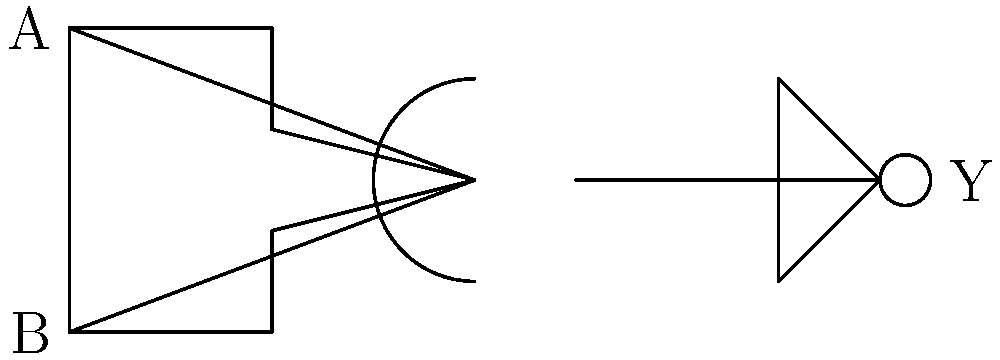In the context of risk assessment for high-tech manufacturing facilities, you encounter a digital circuit schematic. Identify the logic gates in this circuit and determine the truth table for output Y. How might this circuit's behavior relate to a fail-safe mechanism in a manufacturing process? Let's approach this step-by-step:

1) Gate identification:
   - The first gate is an AND gate
   - The second gate is a NOT gate (inverter)

2) Circuit analysis:
   - Inputs A and B feed into the AND gate
   - The output of the AND gate feeds into the NOT gate
   - The output of the NOT gate is Y

3) Truth table construction:
   Let's consider all possible input combinations:

   | A | B | AND output | Y (NOT of AND) |
   |---|---|------------|----------------|
   | 0 | 0 |     0      |       1        |
   | 0 | 1 |     0      |       1        |
   | 1 | 0 |     0      |       1        |
   | 1 | 1 |     1      |       0        |

4) Circuit behavior:
   - The output Y is 0 only when both A and B are 1
   - Y is 1 for all other input combinations

5) Relation to fail-safe mechanism:
   In a manufacturing context, this circuit could represent a safety interlock system. For example:
   - A and B could be two separate safety conditions that must both be met (both 1) for a dangerous operation to occur (Y becomes 0)
   - If either safety condition is not met (either A or B is 0), the output Y remains 1, potentially keeping the system in a safe state
   - This design ensures that the system defaults to a safe state (Y = 1) unless very specific conditions are met, which is a common principle in fail-safe design

Understanding such circuits is crucial for a reinsurance broker assessing risks in high-tech manufacturing facilities, as it provides insight into the safety systems in place and potential failure modes.
Answer: AND gate followed by NOT gate; Y = 1 except when A = B = 1; fail-safe design defaulting to safe state. 